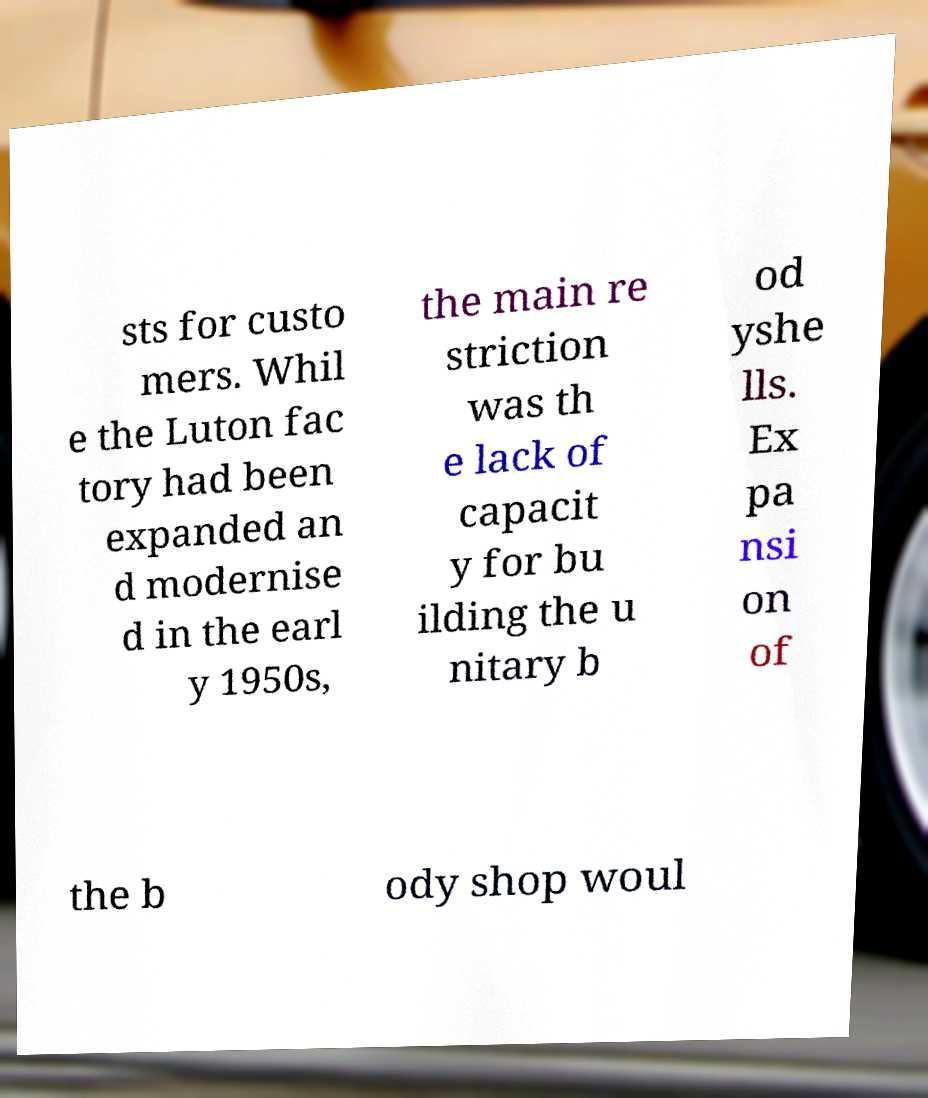Could you assist in decoding the text presented in this image and type it out clearly? sts for custo mers. Whil e the Luton fac tory had been expanded an d modernise d in the earl y 1950s, the main re striction was th e lack of capacit y for bu ilding the u nitary b od yshe lls. Ex pa nsi on of the b ody shop woul 